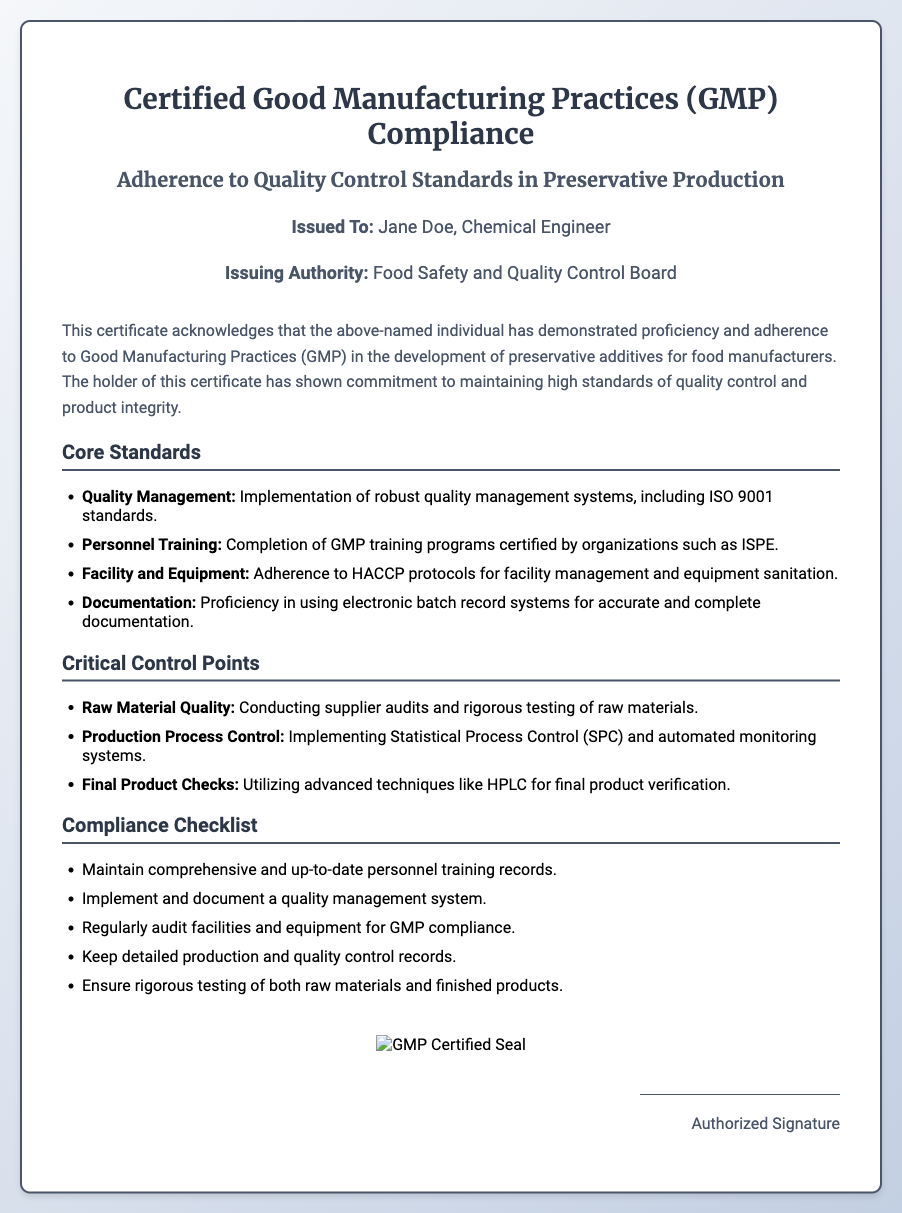What is the title of the certificate? The title is prominently displayed at the top of the document.
Answer: Certified Good Manufacturing Practices (GMP) Compliance Who is the certificate issued to? The document specifies the name of the individual to whom the certificate is issued.
Answer: Jane Doe Which authority issued the certificate? The name of the issuing authority is mentioned below the name of the individual.
Answer: Food Safety and Quality Control Board What is the first core standard outlined in the document? The first item listed in the core standards section is sought.
Answer: Quality Management How many critical control points are listed? The total number of critical control points can be counted from the section.
Answer: Three What method is mentioned for final product verification? The document states a specific technique used for verifying the final product.
Answer: HPLC What type of training programs are referenced in the document? The training programs mentioned related to GMP are identified.
Answer: GMP training programs What is required according to the compliance checklist regarding personnel training records? The compliance checklist specifies a requirement related to training records.
Answer: Maintain comprehensive and up-to-date personnel training records What is the color of the certificate's border? The border color of the certificate can be determined by its design description.
Answer: Dark gray 